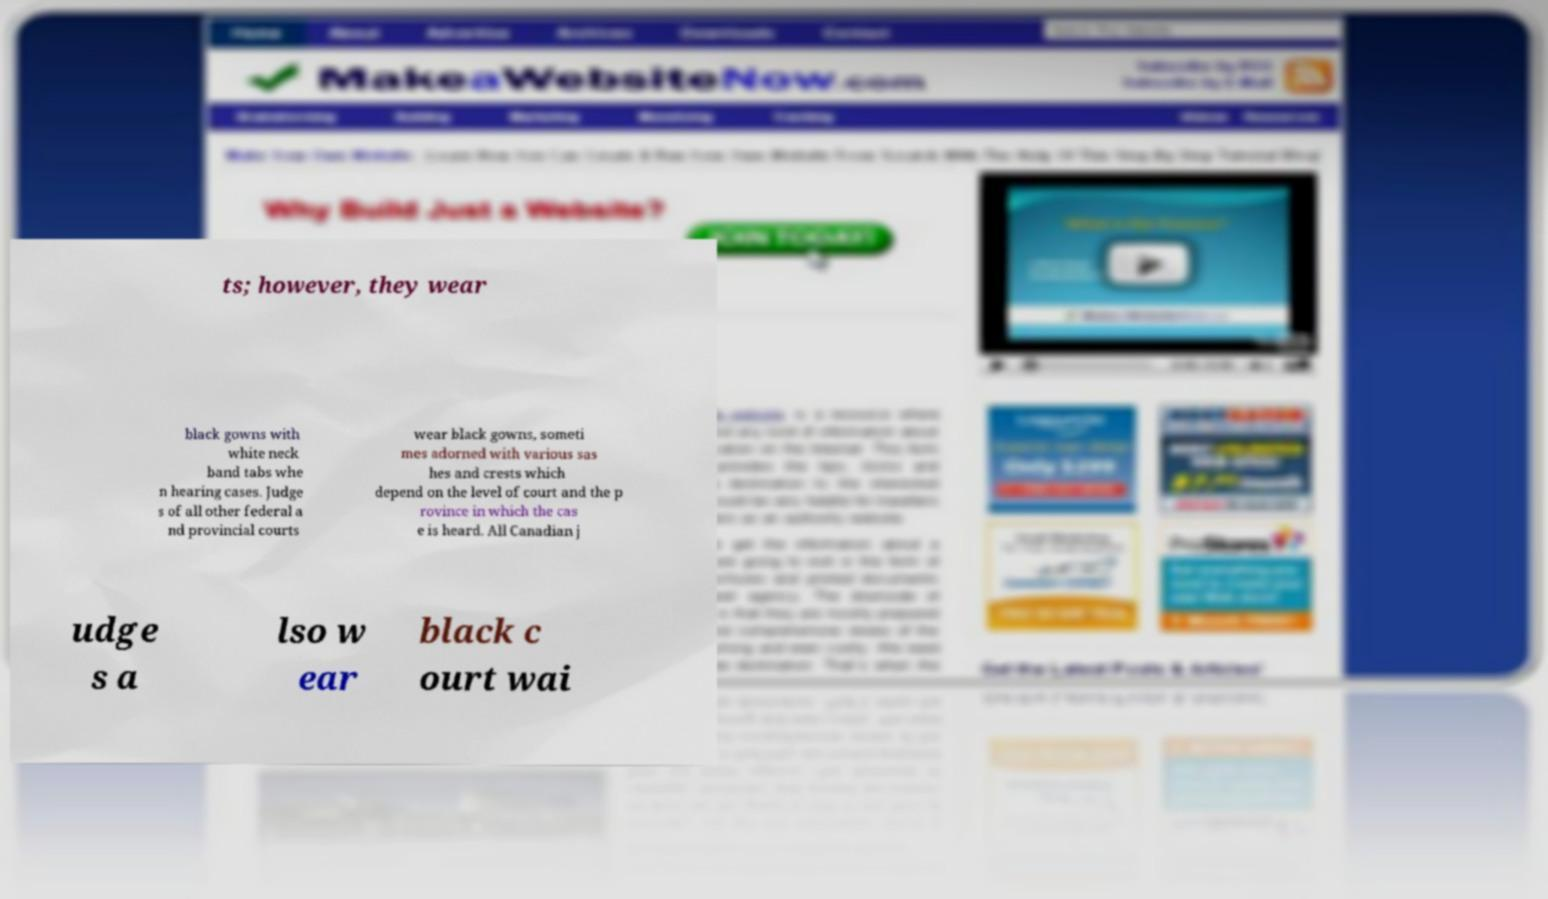Please identify and transcribe the text found in this image. ts; however, they wear black gowns with white neck band tabs whe n hearing cases. Judge s of all other federal a nd provincial courts wear black gowns, someti mes adorned with various sas hes and crests which depend on the level of court and the p rovince in which the cas e is heard. All Canadian j udge s a lso w ear black c ourt wai 